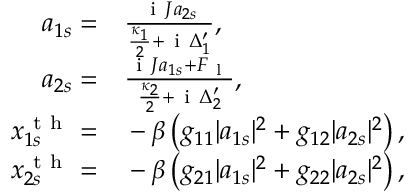<formula> <loc_0><loc_0><loc_500><loc_500>\begin{array} { r l } { a _ { 1 s } = } & \frac { i J a _ { 2 s } } { \frac { \kappa _ { 1 } } { 2 } + i \Delta _ { 1 } ^ { \prime } } , } \\ { a _ { 2 s } = } & \frac { i J a _ { 1 s } + F _ { l } } { \frac { \kappa _ { 2 } } { 2 } + i \Delta _ { 2 } ^ { \prime } } , } \\ { x _ { 1 s } ^ { t h } = } & - \beta \left ( g _ { 1 1 } | a _ { 1 s } | ^ { 2 } + g _ { 1 2 } | a _ { 2 s } | ^ { 2 } \right ) , } \\ { x _ { 2 s } ^ { t h } = } & - \beta \left ( g _ { 2 1 } | a _ { 1 s } | ^ { 2 } + g _ { 2 2 } | a _ { 2 s } | ^ { 2 } \right ) , } \end{array}</formula> 